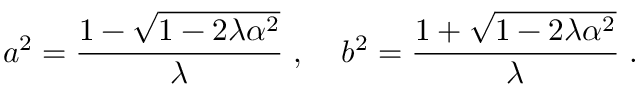<formula> <loc_0><loc_0><loc_500><loc_500>a ^ { 2 } = \frac { 1 - \sqrt { 1 - 2 \lambda \alpha ^ { 2 } } } { \lambda } \, , \, b ^ { 2 } = \frac { 1 + \sqrt { 1 - 2 \lambda \alpha ^ { 2 } } } { \lambda } \, .</formula> 